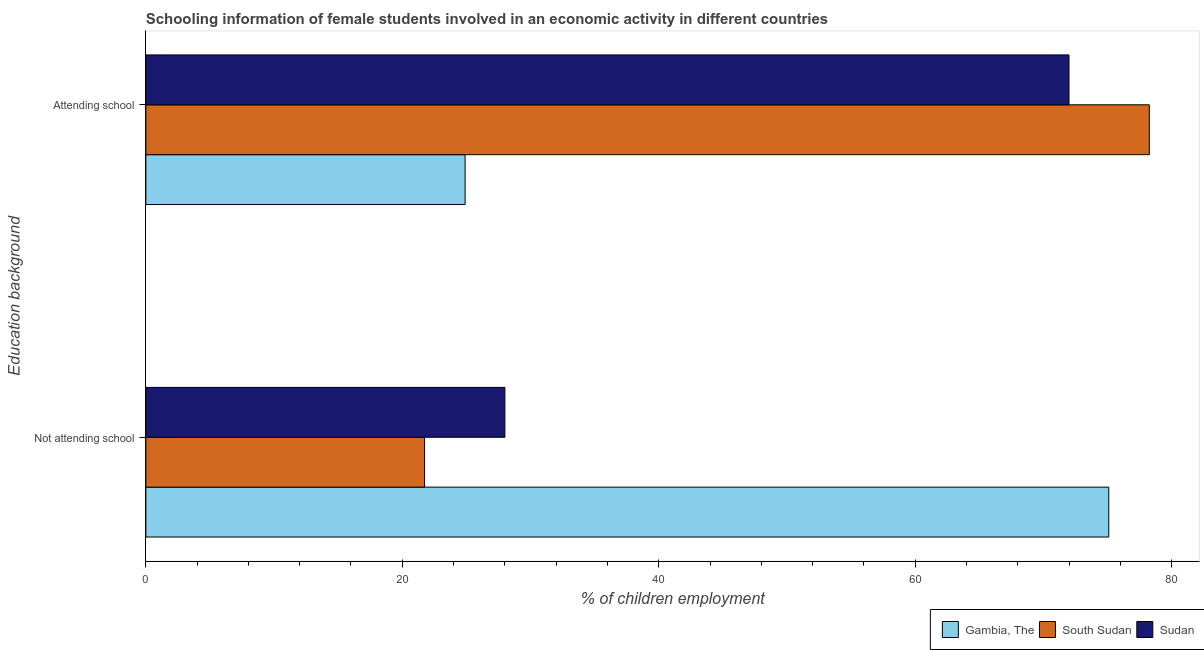How many groups of bars are there?
Offer a terse response. 2. Are the number of bars per tick equal to the number of legend labels?
Provide a succinct answer. Yes. How many bars are there on the 2nd tick from the top?
Your response must be concise. 3. What is the label of the 2nd group of bars from the top?
Make the answer very short. Not attending school. What is the percentage of employed females who are attending school in South Sudan?
Provide a succinct answer. 78.26. Across all countries, what is the maximum percentage of employed females who are attending school?
Offer a terse response. 78.26. Across all countries, what is the minimum percentage of employed females who are not attending school?
Ensure brevity in your answer.  21.74. In which country was the percentage of employed females who are not attending school maximum?
Keep it short and to the point. Gambia, The. In which country was the percentage of employed females who are not attending school minimum?
Provide a succinct answer. South Sudan. What is the total percentage of employed females who are not attending school in the graph?
Offer a terse response. 124.84. What is the difference between the percentage of employed females who are not attending school in South Sudan and that in Gambia, The?
Offer a very short reply. -53.36. What is the difference between the percentage of employed females who are not attending school in Sudan and the percentage of employed females who are attending school in South Sudan?
Ensure brevity in your answer.  -50.26. What is the average percentage of employed females who are not attending school per country?
Your answer should be compact. 41.61. What is the difference between the percentage of employed females who are not attending school and percentage of employed females who are attending school in South Sudan?
Make the answer very short. -56.53. What is the ratio of the percentage of employed females who are not attending school in South Sudan to that in Gambia, The?
Offer a very short reply. 0.29. Is the percentage of employed females who are not attending school in Gambia, The less than that in Sudan?
Your answer should be very brief. No. In how many countries, is the percentage of employed females who are not attending school greater than the average percentage of employed females who are not attending school taken over all countries?
Provide a succinct answer. 1. What does the 2nd bar from the top in Not attending school represents?
Ensure brevity in your answer.  South Sudan. What does the 2nd bar from the bottom in Attending school represents?
Keep it short and to the point. South Sudan. Are all the bars in the graph horizontal?
Ensure brevity in your answer.  Yes. How many countries are there in the graph?
Ensure brevity in your answer.  3. Does the graph contain any zero values?
Keep it short and to the point. No. Where does the legend appear in the graph?
Offer a terse response. Bottom right. How are the legend labels stacked?
Provide a succinct answer. Horizontal. What is the title of the graph?
Give a very brief answer. Schooling information of female students involved in an economic activity in different countries. What is the label or title of the X-axis?
Ensure brevity in your answer.  % of children employment. What is the label or title of the Y-axis?
Provide a short and direct response. Education background. What is the % of children employment of Gambia, The in Not attending school?
Your answer should be very brief. 75.1. What is the % of children employment in South Sudan in Not attending school?
Keep it short and to the point. 21.74. What is the % of children employment of Sudan in Not attending school?
Keep it short and to the point. 28. What is the % of children employment of Gambia, The in Attending school?
Offer a terse response. 24.9. What is the % of children employment of South Sudan in Attending school?
Make the answer very short. 78.26. What is the % of children employment in Sudan in Attending school?
Give a very brief answer. 72. Across all Education background, what is the maximum % of children employment of Gambia, The?
Your answer should be compact. 75.1. Across all Education background, what is the maximum % of children employment of South Sudan?
Offer a terse response. 78.26. Across all Education background, what is the maximum % of children employment in Sudan?
Make the answer very short. 72. Across all Education background, what is the minimum % of children employment in Gambia, The?
Offer a very short reply. 24.9. Across all Education background, what is the minimum % of children employment of South Sudan?
Keep it short and to the point. 21.74. Across all Education background, what is the minimum % of children employment in Sudan?
Provide a succinct answer. 28. What is the total % of children employment of Gambia, The in the graph?
Your answer should be compact. 100. What is the total % of children employment in South Sudan in the graph?
Your answer should be very brief. 100. What is the total % of children employment in Sudan in the graph?
Give a very brief answer. 100. What is the difference between the % of children employment of Gambia, The in Not attending school and that in Attending school?
Make the answer very short. 50.2. What is the difference between the % of children employment in South Sudan in Not attending school and that in Attending school?
Make the answer very short. -56.53. What is the difference between the % of children employment of Sudan in Not attending school and that in Attending school?
Your answer should be compact. -43.99. What is the difference between the % of children employment in Gambia, The in Not attending school and the % of children employment in South Sudan in Attending school?
Offer a terse response. -3.16. What is the difference between the % of children employment of Gambia, The in Not attending school and the % of children employment of Sudan in Attending school?
Your response must be concise. 3.1. What is the difference between the % of children employment of South Sudan in Not attending school and the % of children employment of Sudan in Attending school?
Offer a terse response. -50.26. What is the average % of children employment in South Sudan per Education background?
Make the answer very short. 50. What is the difference between the % of children employment in Gambia, The and % of children employment in South Sudan in Not attending school?
Your answer should be very brief. 53.36. What is the difference between the % of children employment in Gambia, The and % of children employment in Sudan in Not attending school?
Give a very brief answer. 47.1. What is the difference between the % of children employment in South Sudan and % of children employment in Sudan in Not attending school?
Give a very brief answer. -6.27. What is the difference between the % of children employment of Gambia, The and % of children employment of South Sudan in Attending school?
Offer a very short reply. -53.36. What is the difference between the % of children employment in Gambia, The and % of children employment in Sudan in Attending school?
Make the answer very short. -47.1. What is the difference between the % of children employment in South Sudan and % of children employment in Sudan in Attending school?
Provide a short and direct response. 6.27. What is the ratio of the % of children employment in Gambia, The in Not attending school to that in Attending school?
Your response must be concise. 3.02. What is the ratio of the % of children employment of South Sudan in Not attending school to that in Attending school?
Ensure brevity in your answer.  0.28. What is the ratio of the % of children employment of Sudan in Not attending school to that in Attending school?
Provide a succinct answer. 0.39. What is the difference between the highest and the second highest % of children employment of Gambia, The?
Your answer should be compact. 50.2. What is the difference between the highest and the second highest % of children employment of South Sudan?
Your answer should be very brief. 56.53. What is the difference between the highest and the second highest % of children employment in Sudan?
Provide a succinct answer. 43.99. What is the difference between the highest and the lowest % of children employment in Gambia, The?
Your response must be concise. 50.2. What is the difference between the highest and the lowest % of children employment in South Sudan?
Ensure brevity in your answer.  56.53. What is the difference between the highest and the lowest % of children employment in Sudan?
Make the answer very short. 43.99. 